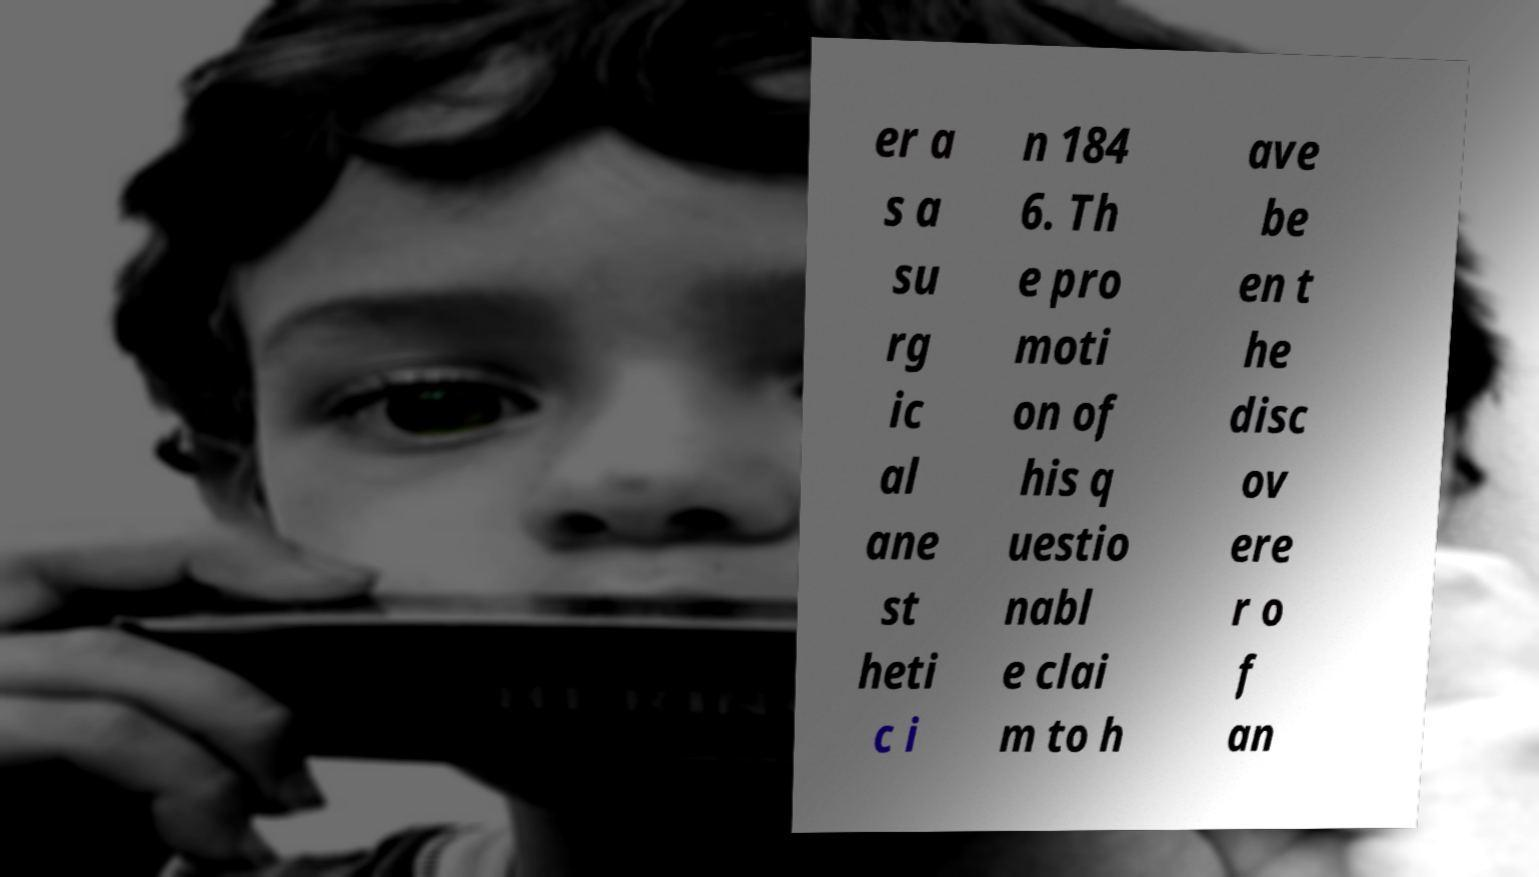Can you read and provide the text displayed in the image?This photo seems to have some interesting text. Can you extract and type it out for me? er a s a su rg ic al ane st heti c i n 184 6. Th e pro moti on of his q uestio nabl e clai m to h ave be en t he disc ov ere r o f an 